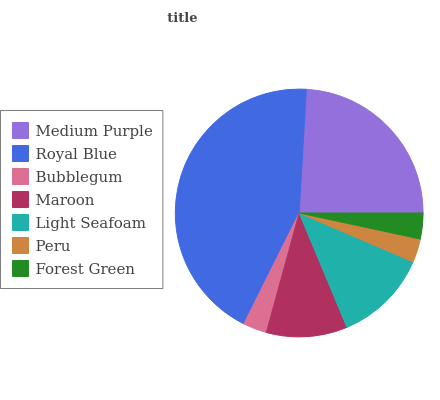Is Peru the minimum?
Answer yes or no. Yes. Is Royal Blue the maximum?
Answer yes or no. Yes. Is Bubblegum the minimum?
Answer yes or no. No. Is Bubblegum the maximum?
Answer yes or no. No. Is Royal Blue greater than Bubblegum?
Answer yes or no. Yes. Is Bubblegum less than Royal Blue?
Answer yes or no. Yes. Is Bubblegum greater than Royal Blue?
Answer yes or no. No. Is Royal Blue less than Bubblegum?
Answer yes or no. No. Is Maroon the high median?
Answer yes or no. Yes. Is Maroon the low median?
Answer yes or no. Yes. Is Light Seafoam the high median?
Answer yes or no. No. Is Medium Purple the low median?
Answer yes or no. No. 